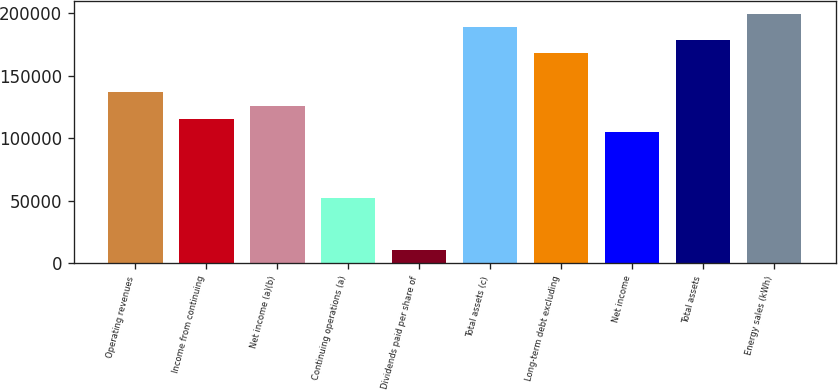Convert chart to OTSL. <chart><loc_0><loc_0><loc_500><loc_500><bar_chart><fcel>Operating revenues<fcel>Income from continuing<fcel>Net income (a)(b)<fcel>Continuing operations (a)<fcel>Dividends paid per share of<fcel>Total assets (c)<fcel>Long-term debt excluding<fcel>Net income<fcel>Total assets<fcel>Energy sales (kWh)<nl><fcel>136641<fcel>115620<fcel>126131<fcel>52554.8<fcel>10511.5<fcel>189196<fcel>168174<fcel>105109<fcel>178685<fcel>199706<nl></chart> 